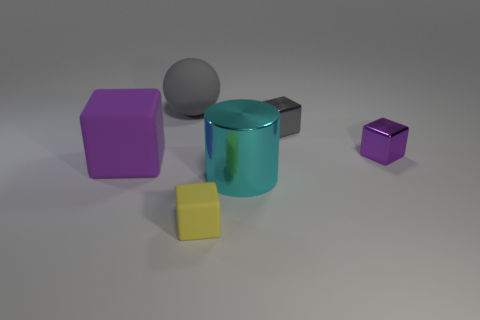Are there any cyan cylinders of the same size as the gray sphere?
Provide a succinct answer. Yes. Are there an equal number of large cylinders that are behind the yellow thing and big matte things on the left side of the sphere?
Ensure brevity in your answer.  Yes. Is the purple block that is right of the small yellow rubber object made of the same material as the gray object right of the sphere?
Offer a terse response. Yes. What is the small yellow object made of?
Give a very brief answer. Rubber. How many other objects are there of the same color as the large rubber sphere?
Provide a short and direct response. 1. How many tiny yellow things are there?
Keep it short and to the point. 1. What material is the tiny cube behind the tiny metallic cube in front of the tiny gray thing made of?
Provide a succinct answer. Metal. There is a purple thing that is the same size as the gray metal thing; what material is it?
Your answer should be very brief. Metal. Is the size of the gray cube to the right of the gray matte sphere the same as the big cyan metal cylinder?
Your answer should be compact. No. Do the purple thing that is to the right of the small yellow cube and the big cyan thing have the same shape?
Make the answer very short. No. 